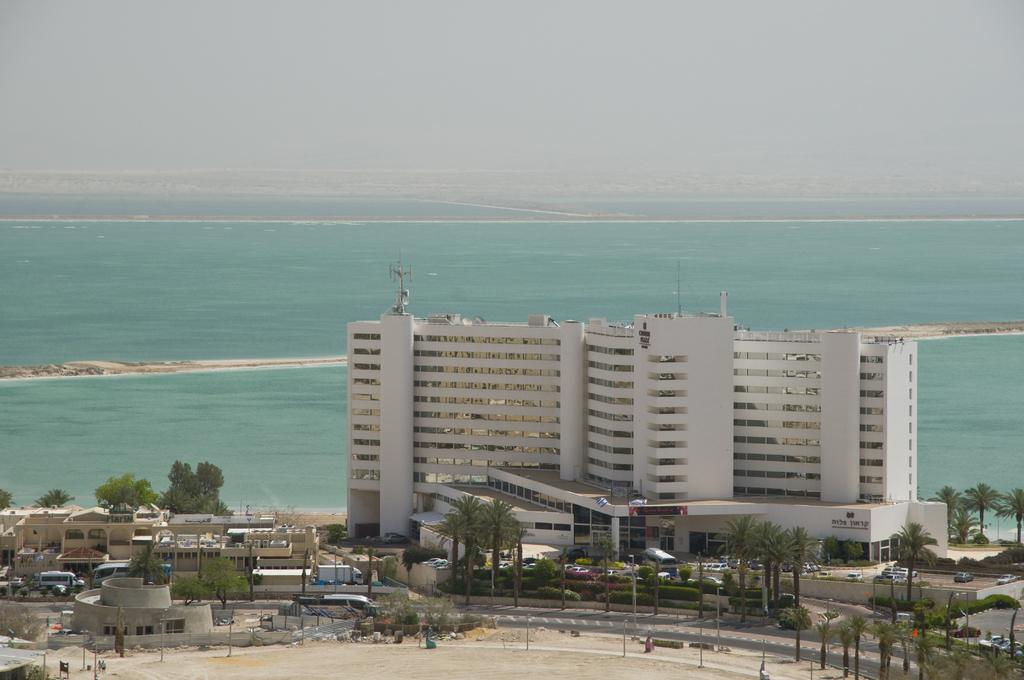What type of structures can be seen in the image? There are buildings in the image. What natural elements are present in the image? There are trees and a river in the image. What type of vegetation is visible in the image? There are plants in the image. What man-made objects can be seen in the image? There are poles in the image. What is happening on the road in the image? There are vehicles moving on the road in the image. What can be seen in the background of the image? The sky is visible in the background of the image. How many frogs are sitting on the sidewalk in the image? There are no frogs or sidewalks present in the image. What story is being told by the people in the image? There are no people or story depicted in the image. 